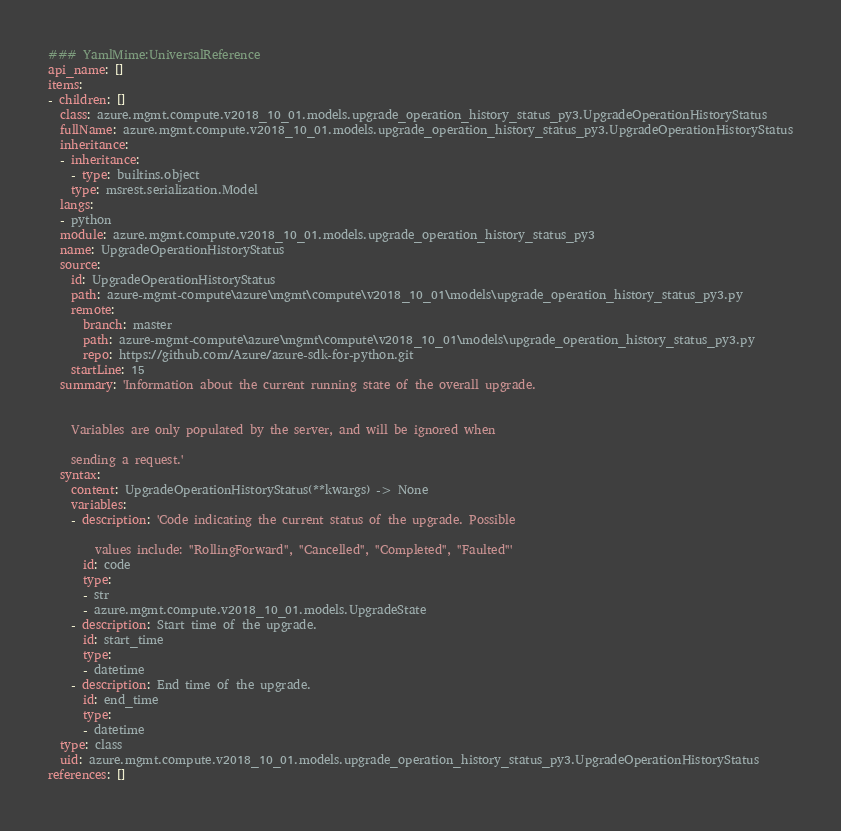<code> <loc_0><loc_0><loc_500><loc_500><_YAML_>### YamlMime:UniversalReference
api_name: []
items:
- children: []
  class: azure.mgmt.compute.v2018_10_01.models.upgrade_operation_history_status_py3.UpgradeOperationHistoryStatus
  fullName: azure.mgmt.compute.v2018_10_01.models.upgrade_operation_history_status_py3.UpgradeOperationHistoryStatus
  inheritance:
  - inheritance:
    - type: builtins.object
    type: msrest.serialization.Model
  langs:
  - python
  module: azure.mgmt.compute.v2018_10_01.models.upgrade_operation_history_status_py3
  name: UpgradeOperationHistoryStatus
  source:
    id: UpgradeOperationHistoryStatus
    path: azure-mgmt-compute\azure\mgmt\compute\v2018_10_01\models\upgrade_operation_history_status_py3.py
    remote:
      branch: master
      path: azure-mgmt-compute\azure\mgmt\compute\v2018_10_01\models\upgrade_operation_history_status_py3.py
      repo: https://github.com/Azure/azure-sdk-for-python.git
    startLine: 15
  summary: 'Information about the current running state of the overall upgrade.


    Variables are only populated by the server, and will be ignored when

    sending a request.'
  syntax:
    content: UpgradeOperationHistoryStatus(**kwargs) -> None
    variables:
    - description: 'Code indicating the current status of the upgrade. Possible

        values include: ''RollingForward'', ''Cancelled'', ''Completed'', ''Faulted'''
      id: code
      type:
      - str
      - azure.mgmt.compute.v2018_10_01.models.UpgradeState
    - description: Start time of the upgrade.
      id: start_time
      type:
      - datetime
    - description: End time of the upgrade.
      id: end_time
      type:
      - datetime
  type: class
  uid: azure.mgmt.compute.v2018_10_01.models.upgrade_operation_history_status_py3.UpgradeOperationHistoryStatus
references: []
</code> 